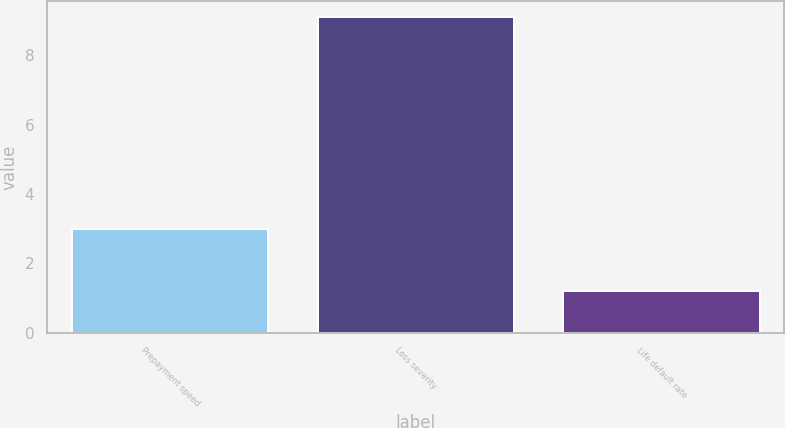Convert chart. <chart><loc_0><loc_0><loc_500><loc_500><bar_chart><fcel>Prepayment speed<fcel>Loss severity<fcel>Life default rate<nl><fcel>3<fcel>9.1<fcel>1.2<nl></chart> 